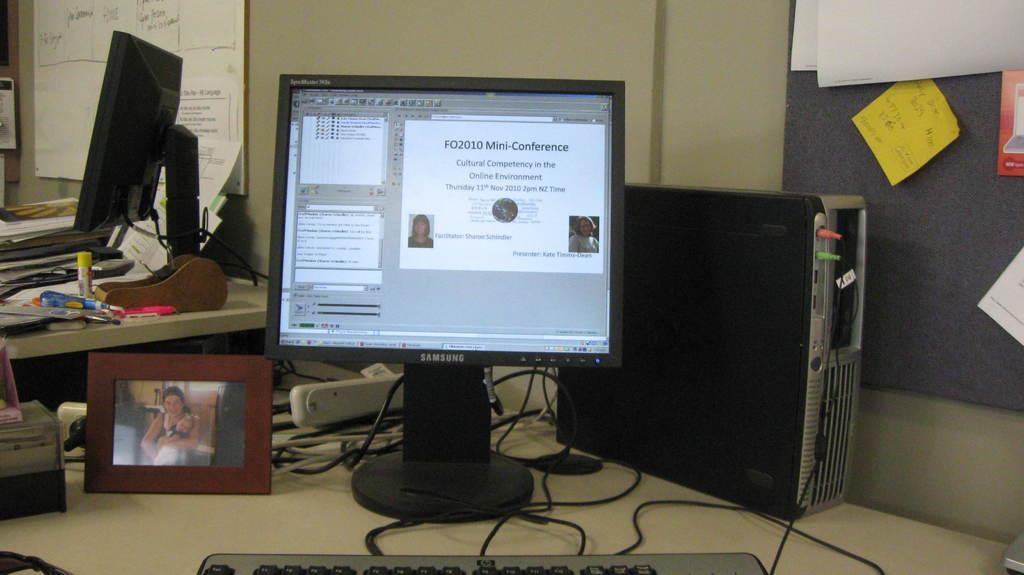Can you describe this image briefly? Here I can see a table on which two monitors, CPU, wires, photo frame, papers and some other objects are placed. In the background there is a wall to which many papers are attached. On the screen I can see some text and two images of persons. 